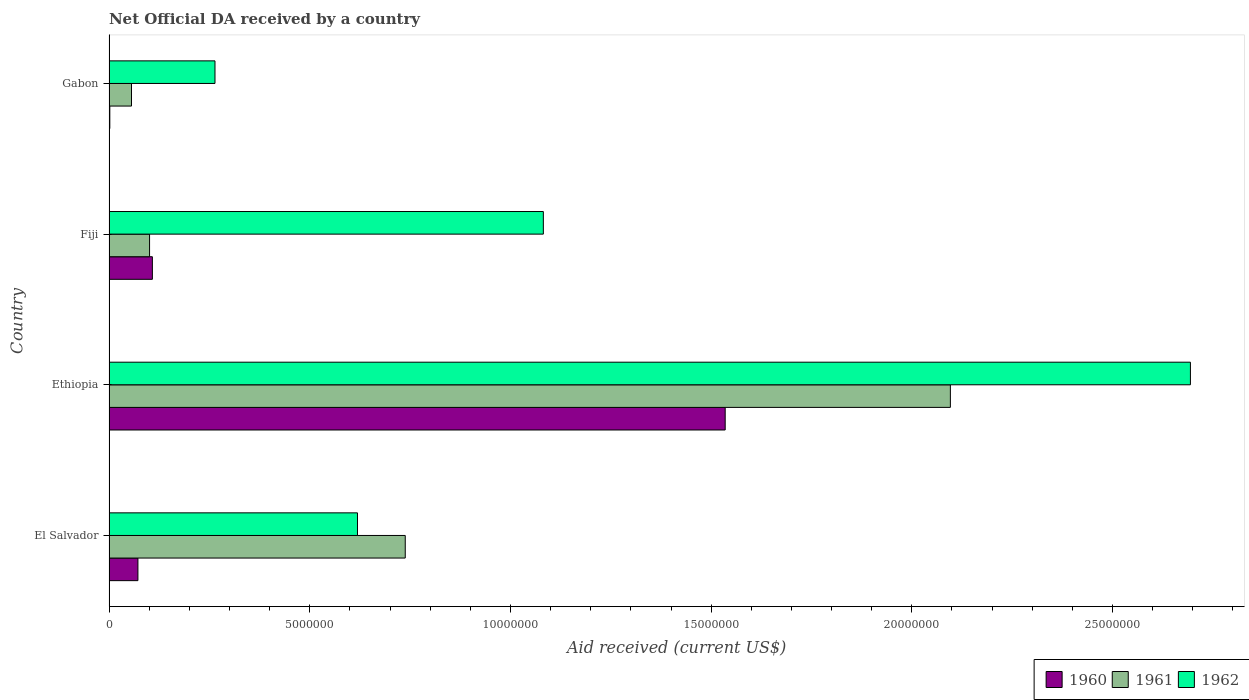How many groups of bars are there?
Provide a succinct answer. 4. Are the number of bars per tick equal to the number of legend labels?
Offer a terse response. Yes. How many bars are there on the 1st tick from the top?
Your answer should be very brief. 3. What is the label of the 3rd group of bars from the top?
Your answer should be compact. Ethiopia. What is the net official development assistance aid received in 1960 in Ethiopia?
Keep it short and to the point. 1.54e+07. Across all countries, what is the maximum net official development assistance aid received in 1962?
Ensure brevity in your answer.  2.69e+07. Across all countries, what is the minimum net official development assistance aid received in 1960?
Provide a succinct answer. 2.00e+04. In which country was the net official development assistance aid received in 1960 maximum?
Your response must be concise. Ethiopia. In which country was the net official development assistance aid received in 1961 minimum?
Your answer should be very brief. Gabon. What is the total net official development assistance aid received in 1960 in the graph?
Your response must be concise. 1.72e+07. What is the difference between the net official development assistance aid received in 1962 in El Salvador and that in Fiji?
Your answer should be compact. -4.63e+06. What is the difference between the net official development assistance aid received in 1962 in El Salvador and the net official development assistance aid received in 1960 in Ethiopia?
Keep it short and to the point. -9.16e+06. What is the average net official development assistance aid received in 1960 per country?
Make the answer very short. 4.29e+06. What is the difference between the net official development assistance aid received in 1961 and net official development assistance aid received in 1960 in Ethiopia?
Your answer should be very brief. 5.61e+06. In how many countries, is the net official development assistance aid received in 1960 greater than 27000000 US$?
Offer a terse response. 0. What is the ratio of the net official development assistance aid received in 1961 in Ethiopia to that in Fiji?
Your answer should be compact. 20.75. Is the difference between the net official development assistance aid received in 1961 in El Salvador and Fiji greater than the difference between the net official development assistance aid received in 1960 in El Salvador and Fiji?
Provide a short and direct response. Yes. What is the difference between the highest and the second highest net official development assistance aid received in 1962?
Keep it short and to the point. 1.61e+07. What is the difference between the highest and the lowest net official development assistance aid received in 1962?
Provide a succinct answer. 2.43e+07. In how many countries, is the net official development assistance aid received in 1962 greater than the average net official development assistance aid received in 1962 taken over all countries?
Make the answer very short. 1. Is it the case that in every country, the sum of the net official development assistance aid received in 1960 and net official development assistance aid received in 1961 is greater than the net official development assistance aid received in 1962?
Offer a very short reply. No. How many bars are there?
Your response must be concise. 12. How many countries are there in the graph?
Offer a terse response. 4. What is the difference between two consecutive major ticks on the X-axis?
Your response must be concise. 5.00e+06. Are the values on the major ticks of X-axis written in scientific E-notation?
Offer a terse response. No. How many legend labels are there?
Your answer should be compact. 3. What is the title of the graph?
Your answer should be very brief. Net Official DA received by a country. What is the label or title of the X-axis?
Make the answer very short. Aid received (current US$). What is the Aid received (current US$) in 1960 in El Salvador?
Make the answer very short. 7.20e+05. What is the Aid received (current US$) of 1961 in El Salvador?
Your answer should be compact. 7.38e+06. What is the Aid received (current US$) of 1962 in El Salvador?
Your response must be concise. 6.19e+06. What is the Aid received (current US$) of 1960 in Ethiopia?
Your answer should be very brief. 1.54e+07. What is the Aid received (current US$) of 1961 in Ethiopia?
Ensure brevity in your answer.  2.10e+07. What is the Aid received (current US$) in 1962 in Ethiopia?
Offer a terse response. 2.69e+07. What is the Aid received (current US$) of 1960 in Fiji?
Ensure brevity in your answer.  1.08e+06. What is the Aid received (current US$) of 1961 in Fiji?
Offer a terse response. 1.01e+06. What is the Aid received (current US$) of 1962 in Fiji?
Provide a succinct answer. 1.08e+07. What is the Aid received (current US$) in 1960 in Gabon?
Keep it short and to the point. 2.00e+04. What is the Aid received (current US$) of 1961 in Gabon?
Offer a terse response. 5.60e+05. What is the Aid received (current US$) in 1962 in Gabon?
Your answer should be compact. 2.64e+06. Across all countries, what is the maximum Aid received (current US$) in 1960?
Ensure brevity in your answer.  1.54e+07. Across all countries, what is the maximum Aid received (current US$) of 1961?
Make the answer very short. 2.10e+07. Across all countries, what is the maximum Aid received (current US$) of 1962?
Provide a succinct answer. 2.69e+07. Across all countries, what is the minimum Aid received (current US$) of 1960?
Your answer should be compact. 2.00e+04. Across all countries, what is the minimum Aid received (current US$) in 1961?
Make the answer very short. 5.60e+05. Across all countries, what is the minimum Aid received (current US$) of 1962?
Your answer should be compact. 2.64e+06. What is the total Aid received (current US$) in 1960 in the graph?
Your answer should be very brief. 1.72e+07. What is the total Aid received (current US$) in 1961 in the graph?
Keep it short and to the point. 2.99e+07. What is the total Aid received (current US$) of 1962 in the graph?
Your answer should be very brief. 4.66e+07. What is the difference between the Aid received (current US$) in 1960 in El Salvador and that in Ethiopia?
Keep it short and to the point. -1.46e+07. What is the difference between the Aid received (current US$) in 1961 in El Salvador and that in Ethiopia?
Keep it short and to the point. -1.36e+07. What is the difference between the Aid received (current US$) of 1962 in El Salvador and that in Ethiopia?
Your response must be concise. -2.08e+07. What is the difference between the Aid received (current US$) of 1960 in El Salvador and that in Fiji?
Your response must be concise. -3.60e+05. What is the difference between the Aid received (current US$) of 1961 in El Salvador and that in Fiji?
Provide a succinct answer. 6.37e+06. What is the difference between the Aid received (current US$) in 1962 in El Salvador and that in Fiji?
Offer a very short reply. -4.63e+06. What is the difference between the Aid received (current US$) in 1960 in El Salvador and that in Gabon?
Your response must be concise. 7.00e+05. What is the difference between the Aid received (current US$) of 1961 in El Salvador and that in Gabon?
Your response must be concise. 6.82e+06. What is the difference between the Aid received (current US$) in 1962 in El Salvador and that in Gabon?
Provide a short and direct response. 3.55e+06. What is the difference between the Aid received (current US$) in 1960 in Ethiopia and that in Fiji?
Your answer should be compact. 1.43e+07. What is the difference between the Aid received (current US$) of 1961 in Ethiopia and that in Fiji?
Your response must be concise. 2.00e+07. What is the difference between the Aid received (current US$) in 1962 in Ethiopia and that in Fiji?
Provide a short and direct response. 1.61e+07. What is the difference between the Aid received (current US$) in 1960 in Ethiopia and that in Gabon?
Provide a short and direct response. 1.53e+07. What is the difference between the Aid received (current US$) of 1961 in Ethiopia and that in Gabon?
Your response must be concise. 2.04e+07. What is the difference between the Aid received (current US$) of 1962 in Ethiopia and that in Gabon?
Give a very brief answer. 2.43e+07. What is the difference between the Aid received (current US$) in 1960 in Fiji and that in Gabon?
Your response must be concise. 1.06e+06. What is the difference between the Aid received (current US$) of 1962 in Fiji and that in Gabon?
Offer a terse response. 8.18e+06. What is the difference between the Aid received (current US$) of 1960 in El Salvador and the Aid received (current US$) of 1961 in Ethiopia?
Your answer should be compact. -2.02e+07. What is the difference between the Aid received (current US$) in 1960 in El Salvador and the Aid received (current US$) in 1962 in Ethiopia?
Keep it short and to the point. -2.62e+07. What is the difference between the Aid received (current US$) of 1961 in El Salvador and the Aid received (current US$) of 1962 in Ethiopia?
Your answer should be very brief. -1.96e+07. What is the difference between the Aid received (current US$) in 1960 in El Salvador and the Aid received (current US$) in 1962 in Fiji?
Make the answer very short. -1.01e+07. What is the difference between the Aid received (current US$) of 1961 in El Salvador and the Aid received (current US$) of 1962 in Fiji?
Offer a terse response. -3.44e+06. What is the difference between the Aid received (current US$) of 1960 in El Salvador and the Aid received (current US$) of 1962 in Gabon?
Offer a very short reply. -1.92e+06. What is the difference between the Aid received (current US$) in 1961 in El Salvador and the Aid received (current US$) in 1962 in Gabon?
Make the answer very short. 4.74e+06. What is the difference between the Aid received (current US$) in 1960 in Ethiopia and the Aid received (current US$) in 1961 in Fiji?
Ensure brevity in your answer.  1.43e+07. What is the difference between the Aid received (current US$) in 1960 in Ethiopia and the Aid received (current US$) in 1962 in Fiji?
Provide a succinct answer. 4.53e+06. What is the difference between the Aid received (current US$) of 1961 in Ethiopia and the Aid received (current US$) of 1962 in Fiji?
Your response must be concise. 1.01e+07. What is the difference between the Aid received (current US$) in 1960 in Ethiopia and the Aid received (current US$) in 1961 in Gabon?
Your answer should be very brief. 1.48e+07. What is the difference between the Aid received (current US$) in 1960 in Ethiopia and the Aid received (current US$) in 1962 in Gabon?
Provide a succinct answer. 1.27e+07. What is the difference between the Aid received (current US$) of 1961 in Ethiopia and the Aid received (current US$) of 1962 in Gabon?
Provide a short and direct response. 1.83e+07. What is the difference between the Aid received (current US$) of 1960 in Fiji and the Aid received (current US$) of 1961 in Gabon?
Make the answer very short. 5.20e+05. What is the difference between the Aid received (current US$) in 1960 in Fiji and the Aid received (current US$) in 1962 in Gabon?
Your response must be concise. -1.56e+06. What is the difference between the Aid received (current US$) in 1961 in Fiji and the Aid received (current US$) in 1962 in Gabon?
Make the answer very short. -1.63e+06. What is the average Aid received (current US$) in 1960 per country?
Keep it short and to the point. 4.29e+06. What is the average Aid received (current US$) of 1961 per country?
Your response must be concise. 7.48e+06. What is the average Aid received (current US$) of 1962 per country?
Give a very brief answer. 1.16e+07. What is the difference between the Aid received (current US$) in 1960 and Aid received (current US$) in 1961 in El Salvador?
Offer a terse response. -6.66e+06. What is the difference between the Aid received (current US$) in 1960 and Aid received (current US$) in 1962 in El Salvador?
Your answer should be very brief. -5.47e+06. What is the difference between the Aid received (current US$) of 1961 and Aid received (current US$) of 1962 in El Salvador?
Your answer should be compact. 1.19e+06. What is the difference between the Aid received (current US$) in 1960 and Aid received (current US$) in 1961 in Ethiopia?
Give a very brief answer. -5.61e+06. What is the difference between the Aid received (current US$) of 1960 and Aid received (current US$) of 1962 in Ethiopia?
Make the answer very short. -1.16e+07. What is the difference between the Aid received (current US$) of 1961 and Aid received (current US$) of 1962 in Ethiopia?
Offer a terse response. -5.98e+06. What is the difference between the Aid received (current US$) in 1960 and Aid received (current US$) in 1961 in Fiji?
Provide a succinct answer. 7.00e+04. What is the difference between the Aid received (current US$) in 1960 and Aid received (current US$) in 1962 in Fiji?
Keep it short and to the point. -9.74e+06. What is the difference between the Aid received (current US$) of 1961 and Aid received (current US$) of 1962 in Fiji?
Make the answer very short. -9.81e+06. What is the difference between the Aid received (current US$) of 1960 and Aid received (current US$) of 1961 in Gabon?
Ensure brevity in your answer.  -5.40e+05. What is the difference between the Aid received (current US$) in 1960 and Aid received (current US$) in 1962 in Gabon?
Your response must be concise. -2.62e+06. What is the difference between the Aid received (current US$) in 1961 and Aid received (current US$) in 1962 in Gabon?
Keep it short and to the point. -2.08e+06. What is the ratio of the Aid received (current US$) of 1960 in El Salvador to that in Ethiopia?
Make the answer very short. 0.05. What is the ratio of the Aid received (current US$) of 1961 in El Salvador to that in Ethiopia?
Your response must be concise. 0.35. What is the ratio of the Aid received (current US$) of 1962 in El Salvador to that in Ethiopia?
Offer a terse response. 0.23. What is the ratio of the Aid received (current US$) in 1960 in El Salvador to that in Fiji?
Your response must be concise. 0.67. What is the ratio of the Aid received (current US$) of 1961 in El Salvador to that in Fiji?
Give a very brief answer. 7.31. What is the ratio of the Aid received (current US$) in 1962 in El Salvador to that in Fiji?
Provide a short and direct response. 0.57. What is the ratio of the Aid received (current US$) in 1960 in El Salvador to that in Gabon?
Provide a short and direct response. 36. What is the ratio of the Aid received (current US$) in 1961 in El Salvador to that in Gabon?
Offer a very short reply. 13.18. What is the ratio of the Aid received (current US$) in 1962 in El Salvador to that in Gabon?
Give a very brief answer. 2.34. What is the ratio of the Aid received (current US$) in 1960 in Ethiopia to that in Fiji?
Provide a short and direct response. 14.21. What is the ratio of the Aid received (current US$) in 1961 in Ethiopia to that in Fiji?
Provide a succinct answer. 20.75. What is the ratio of the Aid received (current US$) of 1962 in Ethiopia to that in Fiji?
Offer a very short reply. 2.49. What is the ratio of the Aid received (current US$) in 1960 in Ethiopia to that in Gabon?
Provide a succinct answer. 767.5. What is the ratio of the Aid received (current US$) in 1961 in Ethiopia to that in Gabon?
Your response must be concise. 37.43. What is the ratio of the Aid received (current US$) in 1962 in Ethiopia to that in Gabon?
Ensure brevity in your answer.  10.2. What is the ratio of the Aid received (current US$) in 1961 in Fiji to that in Gabon?
Provide a short and direct response. 1.8. What is the ratio of the Aid received (current US$) in 1962 in Fiji to that in Gabon?
Keep it short and to the point. 4.1. What is the difference between the highest and the second highest Aid received (current US$) of 1960?
Offer a very short reply. 1.43e+07. What is the difference between the highest and the second highest Aid received (current US$) of 1961?
Your response must be concise. 1.36e+07. What is the difference between the highest and the second highest Aid received (current US$) of 1962?
Ensure brevity in your answer.  1.61e+07. What is the difference between the highest and the lowest Aid received (current US$) of 1960?
Your response must be concise. 1.53e+07. What is the difference between the highest and the lowest Aid received (current US$) in 1961?
Make the answer very short. 2.04e+07. What is the difference between the highest and the lowest Aid received (current US$) in 1962?
Keep it short and to the point. 2.43e+07. 